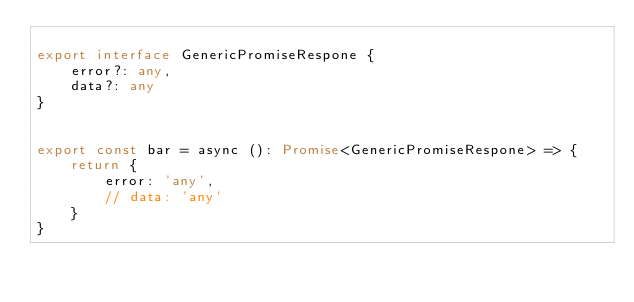Convert code to text. <code><loc_0><loc_0><loc_500><loc_500><_TypeScript_>
export interface GenericPromiseRespone {
    error?: any,
    data?: any
}


export const bar = async (): Promise<GenericPromiseRespone> => {
    return {
        error: 'any',
        // data: 'any'
    }
}
</code> 